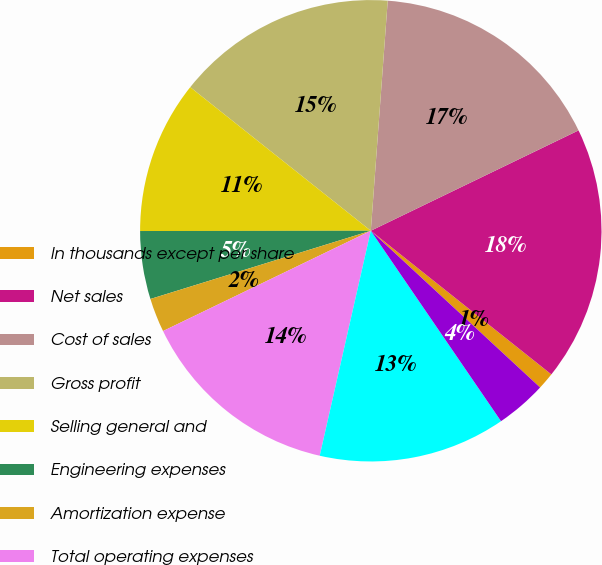Convert chart. <chart><loc_0><loc_0><loc_500><loc_500><pie_chart><fcel>In thousands except per share<fcel>Net sales<fcel>Cost of sales<fcel>Gross profit<fcel>Selling general and<fcel>Engineering expenses<fcel>Amortization expense<fcel>Total operating expenses<fcel>Income from operations<fcel>Interest expense net<nl><fcel>1.19%<fcel>17.86%<fcel>16.67%<fcel>15.48%<fcel>10.71%<fcel>4.76%<fcel>2.38%<fcel>14.29%<fcel>13.1%<fcel>3.57%<nl></chart> 